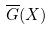<formula> <loc_0><loc_0><loc_500><loc_500>\overline { G } ( X )</formula> 